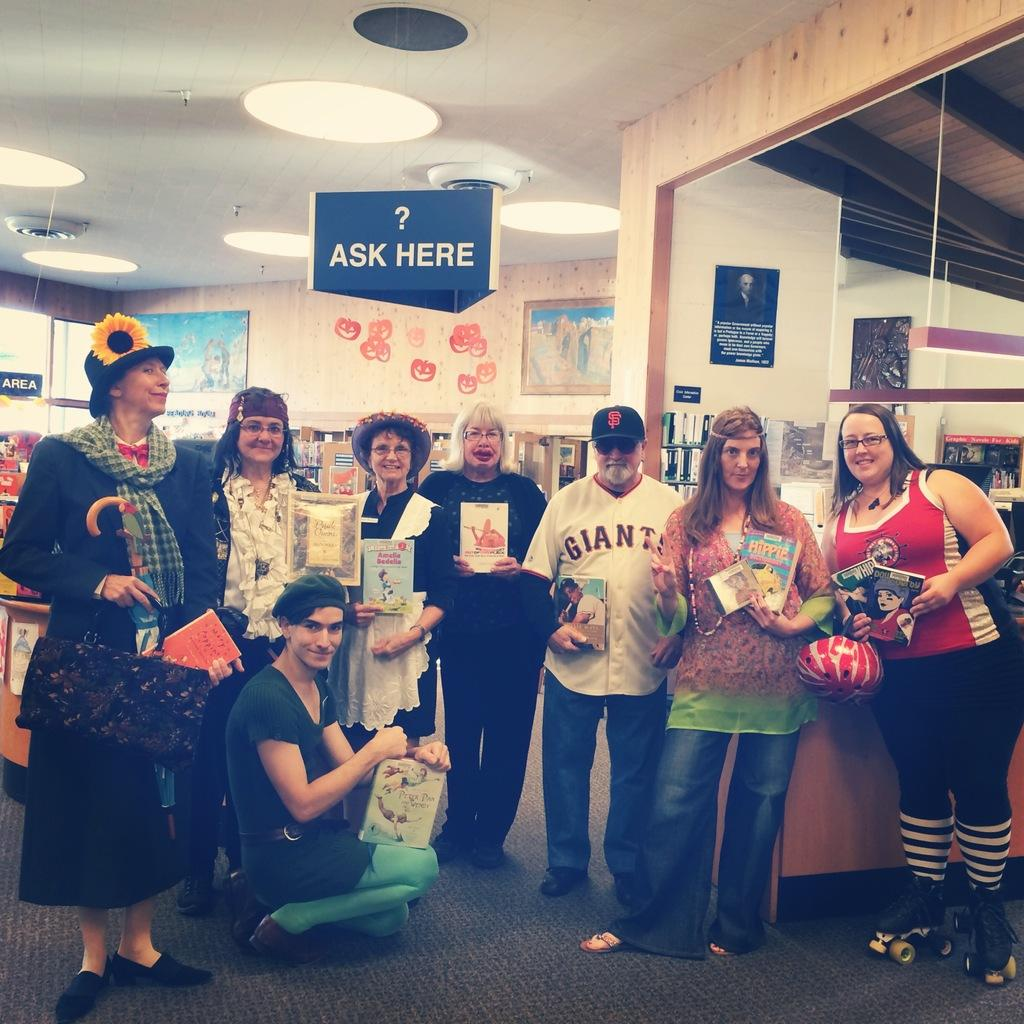Provide a one-sentence caption for the provided image. A group of people hold books in a library under an Ask Here sign. 